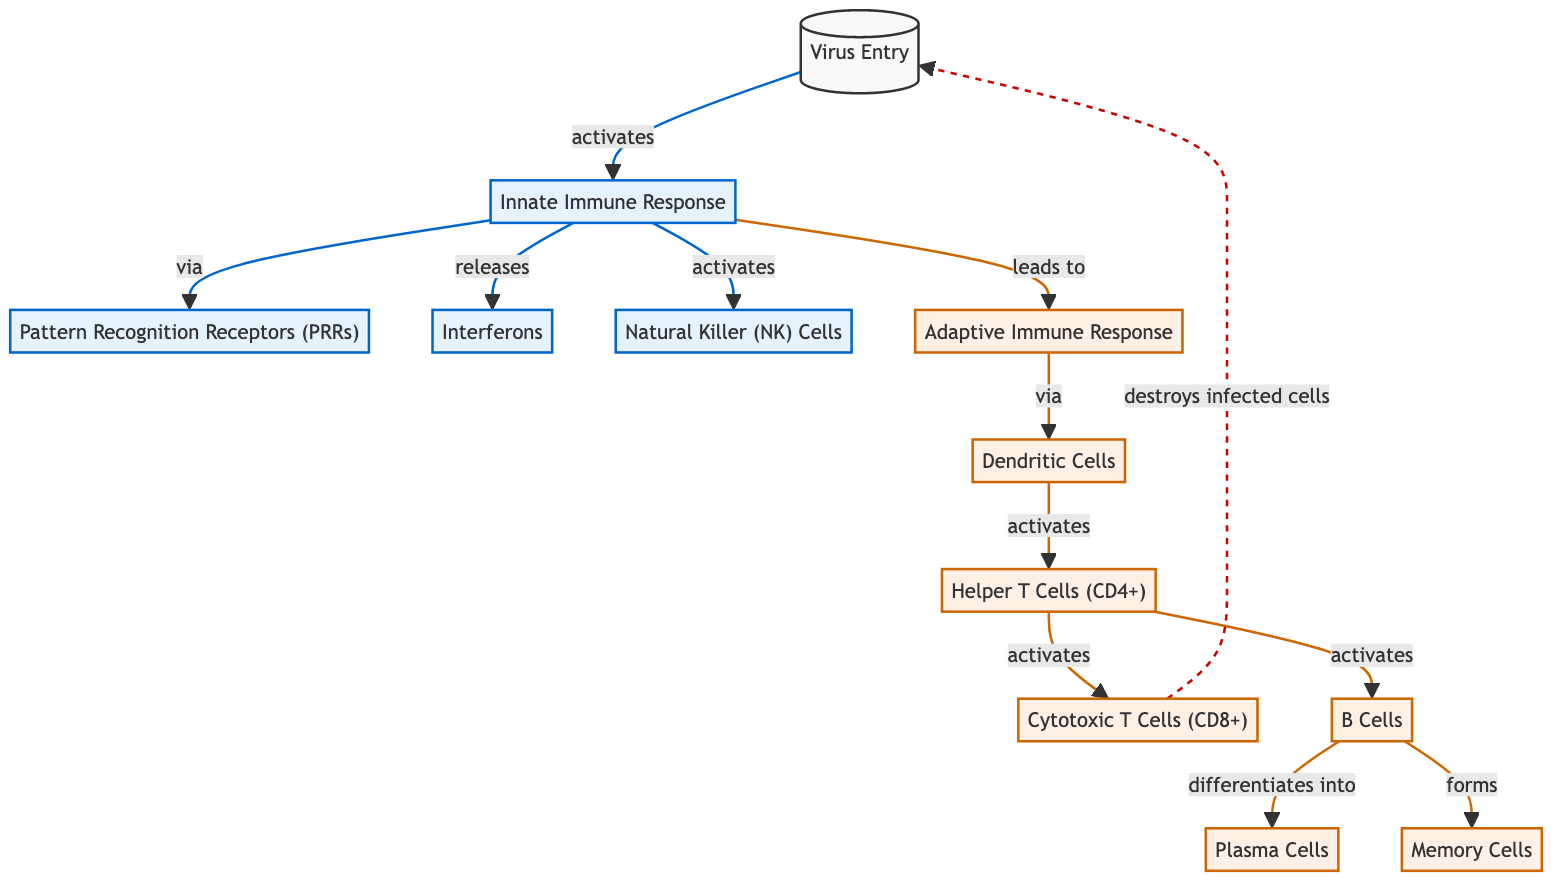What triggers the Innate Immune Response? The initial node, labeled "Virus Entry," activates the "Innate Immune Response" as indicated by the arrow labeled "activates."
Answer: Virus Entry How many primary immune responses are illustrated in the diagram? There are two main responses shown: the "Innate Immune Response" and the "Adaptive Immune Response," each represented as major sections in the diagram.
Answer: 2 What role do Dendritic Cells play in the immune response? "Dendritic Cells" activate "Helper T Cells (CD4+)," indicating their role in bridging innate and adaptive immunity, as shown by the directional arrow.
Answer: activate Which cell type is responsible for destroying infected cells? The diagram indicates that "Cytotoxic T Cells (CD8+)" are responsible for destroying infected cells, as indicated by the dashed line leading to "Virus Entry."
Answer: Cytotoxic T Cells (CD8+) What are the two main pathways following the activation of the Innate Immune Response? After being activated, the Innate Immune Response leads to "Pattern Recognition Receptors (PRRs)" and releases "Interferons," represented by arrows that illustrate these two outcomes.
Answer: PRRs and Interferons How does the Adaptive Immune Response get activated? The "Innate Immune Response" leads to the "Adaptive Immune Response" activation via "Dendritic Cells," which is indicated by the direction of the flow from the innate response to the adaptive response section.
Answer: Dendritic Cells Which immune cells differentiate into Plasma Cells? B Cells differentiate into Plasma Cells, as described in the diagram where an arrow leads from "B Cells" to "Plasma Cells."
Answer: B Cells What type of cells are Memory Cells derived from? "Memory Cells" are derived from "B Cells," as indicated by the flow from "B Cells" to the "Memory Cells" node in the diagram.
Answer: B Cells What do Interferons primarily release? Interferons are shown to be released by the "Innate Immune Response," indicating their role in signaling and promoting the immune function, as depicted by the arrows in the diagram.
Answer: signaling 